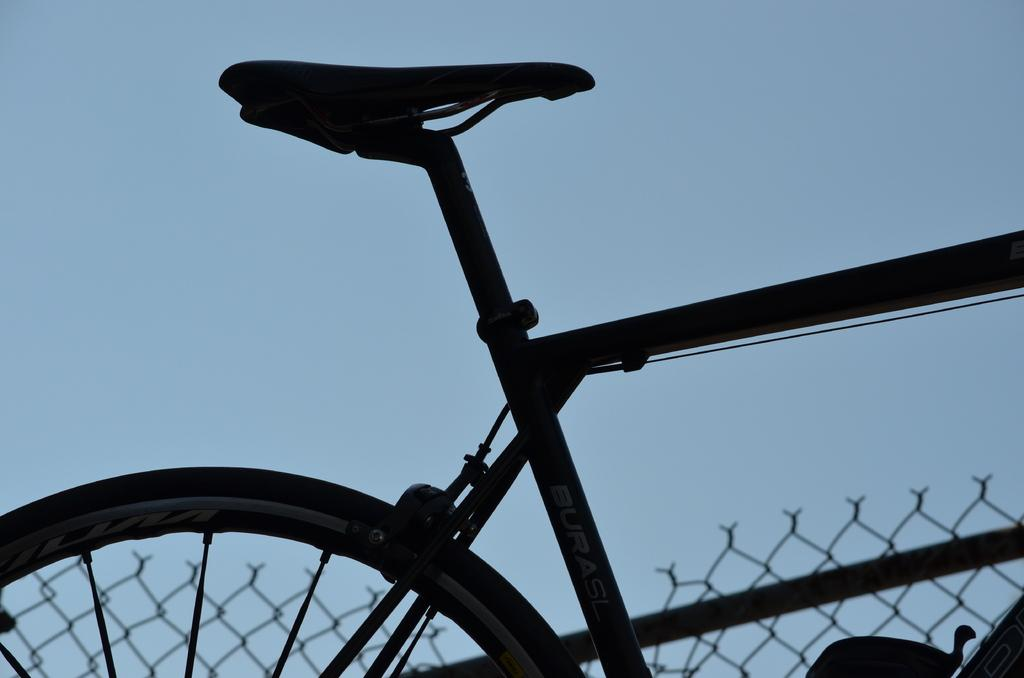What is the main object in the image? There is a bicycle in the image. What can be seen in the background of the image? There is a fence in the background of the image. What type of fang can be seen on the bicycle in the image? There are no fangs present on the bicycle in the image. 